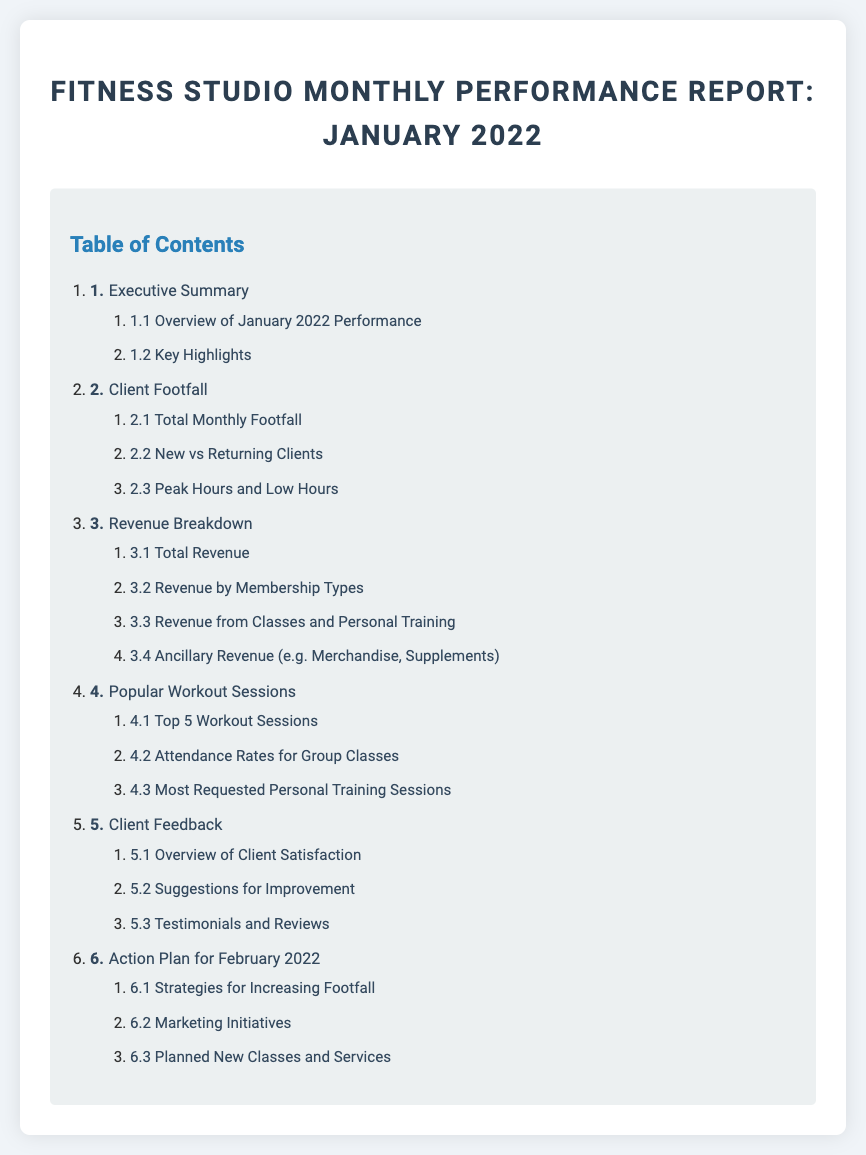What section discusses client satisfaction? The section that covers client satisfaction is labeled as "Client Feedback," which provides an overview and insights into feedback from clients.
Answer: Client Feedback How many total sections are there in the report? The report contains six main sections, as outlined in the table of contents from 1 to 6.
Answer: Six What is discussed in subsection 3.2? Subsection 3.2 focuses on the revenue breakdown by membership types, detailing how much revenue each membership category generates.
Answer: Revenue by Membership Types What are the top 5 workout sessions? The top 5 workout sessions are listed in subsection 4.1 of the report, which specifically identifies the most popular workouts among clients.
Answer: Top 5 Workout Sessions What recommendations can be found in the action plan? The action plan includes strategies for increasing footfall, marketing initiatives, and planned new classes and services for the following month.
Answer: Strategies for Increasing Footfall What month does this performance report cover? The performance report is specifically focused on the month of January 2022, as indicated in the title.
Answer: January 2022 